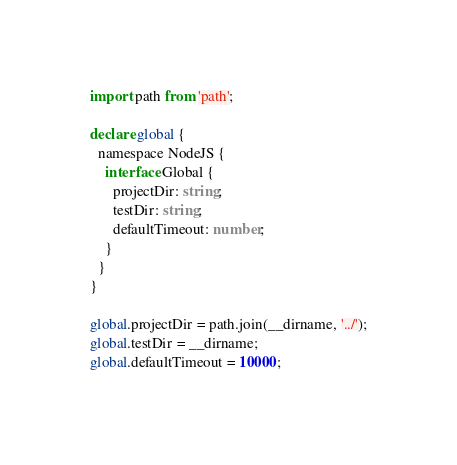Convert code to text. <code><loc_0><loc_0><loc_500><loc_500><_TypeScript_>import path from 'path';

declare global {
  namespace NodeJS {
    interface Global {
      projectDir: string;
      testDir: string;
      defaultTimeout: number;
    }
  }
}

global.projectDir = path.join(__dirname, '../');
global.testDir = __dirname;
global.defaultTimeout = 10000;
</code> 